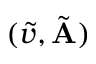Convert formula to latex. <formula><loc_0><loc_0><loc_500><loc_500>( \tilde { v } , \tilde { A } )</formula> 